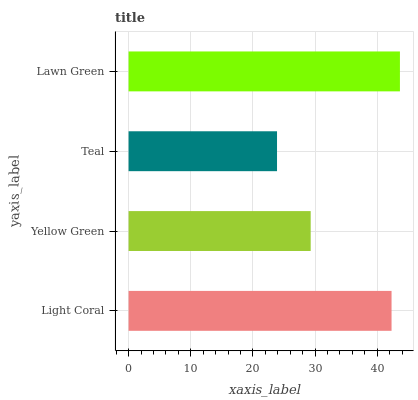Is Teal the minimum?
Answer yes or no. Yes. Is Lawn Green the maximum?
Answer yes or no. Yes. Is Yellow Green the minimum?
Answer yes or no. No. Is Yellow Green the maximum?
Answer yes or no. No. Is Light Coral greater than Yellow Green?
Answer yes or no. Yes. Is Yellow Green less than Light Coral?
Answer yes or no. Yes. Is Yellow Green greater than Light Coral?
Answer yes or no. No. Is Light Coral less than Yellow Green?
Answer yes or no. No. Is Light Coral the high median?
Answer yes or no. Yes. Is Yellow Green the low median?
Answer yes or no. Yes. Is Teal the high median?
Answer yes or no. No. Is Teal the low median?
Answer yes or no. No. 